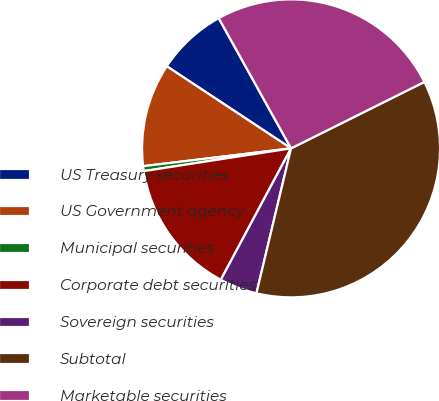Convert chart. <chart><loc_0><loc_0><loc_500><loc_500><pie_chart><fcel>US Treasury securities<fcel>US Government agency<fcel>Municipal securities<fcel>Corporate debt securities<fcel>Sovereign securities<fcel>Subtotal<fcel>Marketable securities<nl><fcel>7.64%<fcel>11.2%<fcel>0.53%<fcel>14.75%<fcel>4.08%<fcel>36.09%<fcel>25.71%<nl></chart> 